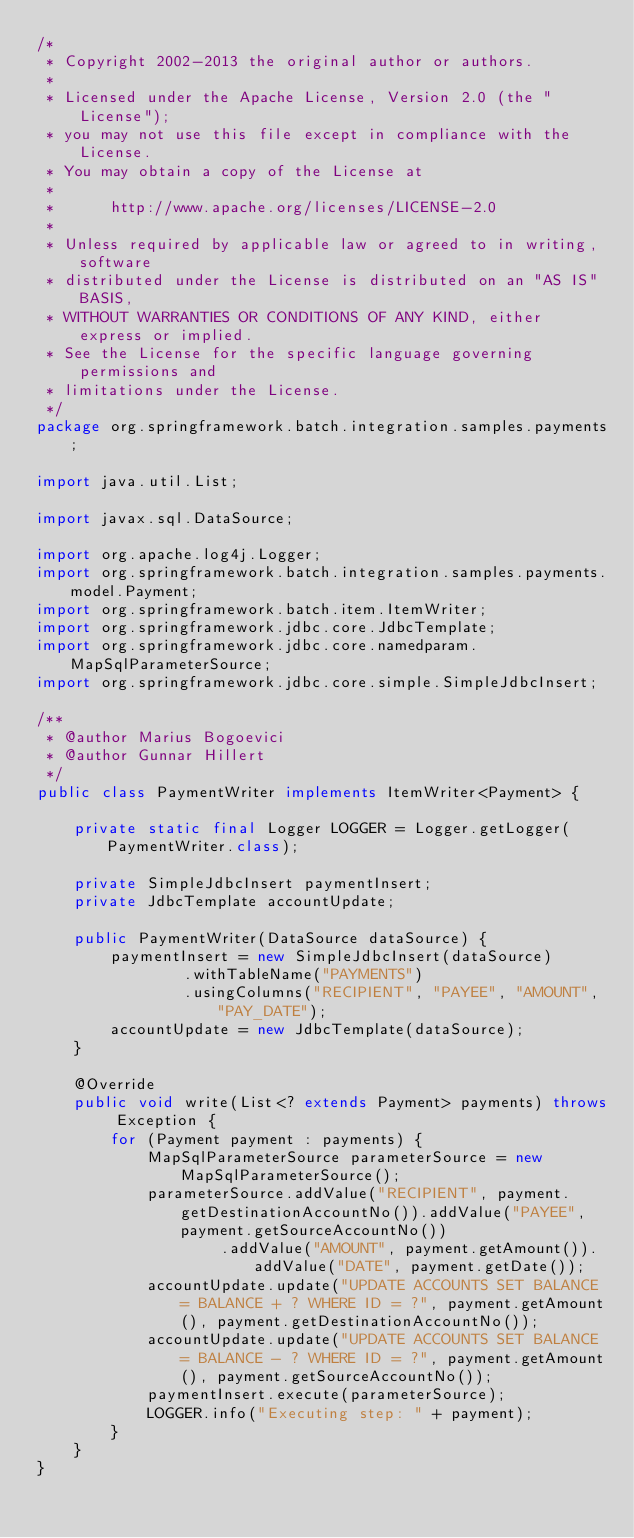Convert code to text. <code><loc_0><loc_0><loc_500><loc_500><_Java_>/*
 * Copyright 2002-2013 the original author or authors.
 *
 * Licensed under the Apache License, Version 2.0 (the "License");
 * you may not use this file except in compliance with the License.
 * You may obtain a copy of the License at
 *
 *      http://www.apache.org/licenses/LICENSE-2.0
 *
 * Unless required by applicable law or agreed to in writing, software
 * distributed under the License is distributed on an "AS IS" BASIS,
 * WITHOUT WARRANTIES OR CONDITIONS OF ANY KIND, either express or implied.
 * See the License for the specific language governing permissions and
 * limitations under the License.
 */
package org.springframework.batch.integration.samples.payments;

import java.util.List;

import javax.sql.DataSource;

import org.apache.log4j.Logger;
import org.springframework.batch.integration.samples.payments.model.Payment;
import org.springframework.batch.item.ItemWriter;
import org.springframework.jdbc.core.JdbcTemplate;
import org.springframework.jdbc.core.namedparam.MapSqlParameterSource;
import org.springframework.jdbc.core.simple.SimpleJdbcInsert;

/**
 * @author Marius Bogoevici
 * @author Gunnar Hillert
 */
public class PaymentWriter implements ItemWriter<Payment> {

	private static final Logger LOGGER = Logger.getLogger(PaymentWriter.class);

	private SimpleJdbcInsert paymentInsert;
	private JdbcTemplate accountUpdate;

	public PaymentWriter(DataSource dataSource) {
		paymentInsert = new SimpleJdbcInsert(dataSource)
				.withTableName("PAYMENTS")
				.usingColumns("RECIPIENT", "PAYEE", "AMOUNT", "PAY_DATE");
		accountUpdate = new JdbcTemplate(dataSource);
	}

	@Override
	public void write(List<? extends Payment> payments) throws Exception {
		for (Payment payment : payments) {
			MapSqlParameterSource parameterSource = new MapSqlParameterSource();
			parameterSource.addValue("RECIPIENT", payment.getDestinationAccountNo()).addValue("PAYEE", payment.getSourceAccountNo())
					.addValue("AMOUNT", payment.getAmount()).addValue("DATE", payment.getDate());
			accountUpdate.update("UPDATE ACCOUNTS SET BALANCE = BALANCE + ? WHERE ID = ?", payment.getAmount(), payment.getDestinationAccountNo());
			accountUpdate.update("UPDATE ACCOUNTS SET BALANCE = BALANCE - ? WHERE ID = ?", payment.getAmount(), payment.getSourceAccountNo());
			paymentInsert.execute(parameterSource);
			LOGGER.info("Executing step: " + payment);
		}
	}
}
</code> 